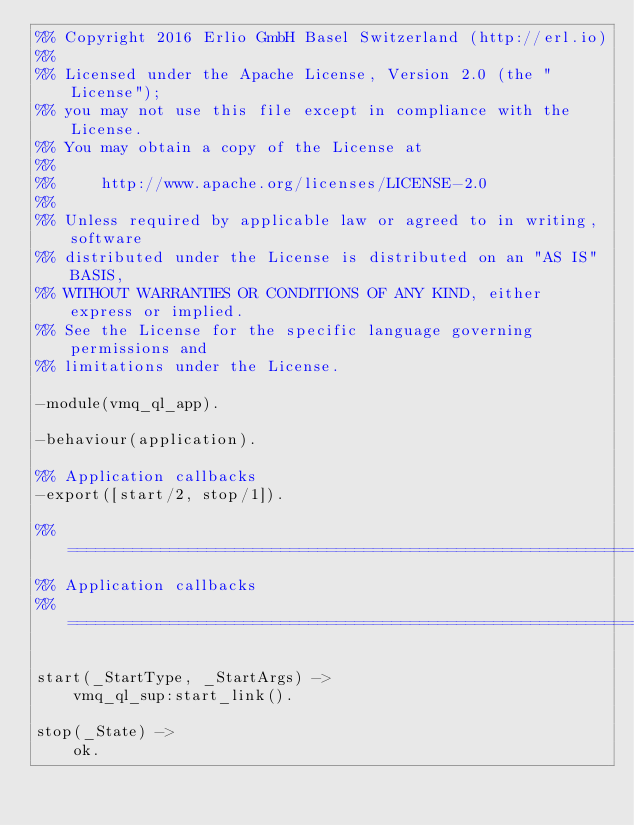Convert code to text. <code><loc_0><loc_0><loc_500><loc_500><_Erlang_>%% Copyright 2016 Erlio GmbH Basel Switzerland (http://erl.io)
%%
%% Licensed under the Apache License, Version 2.0 (the "License");
%% you may not use this file except in compliance with the License.
%% You may obtain a copy of the License at
%%
%%     http://www.apache.org/licenses/LICENSE-2.0
%%
%% Unless required by applicable law or agreed to in writing, software
%% distributed under the License is distributed on an "AS IS" BASIS,
%% WITHOUT WARRANTIES OR CONDITIONS OF ANY KIND, either express or implied.
%% See the License for the specific language governing permissions and
%% limitations under the License.

-module(vmq_ql_app).

-behaviour(application).

%% Application callbacks
-export([start/2, stop/1]).

%% ===================================================================
%% Application callbacks
%% ===================================================================

start(_StartType, _StartArgs) ->
    vmq_ql_sup:start_link().

stop(_State) ->
    ok.
</code> 